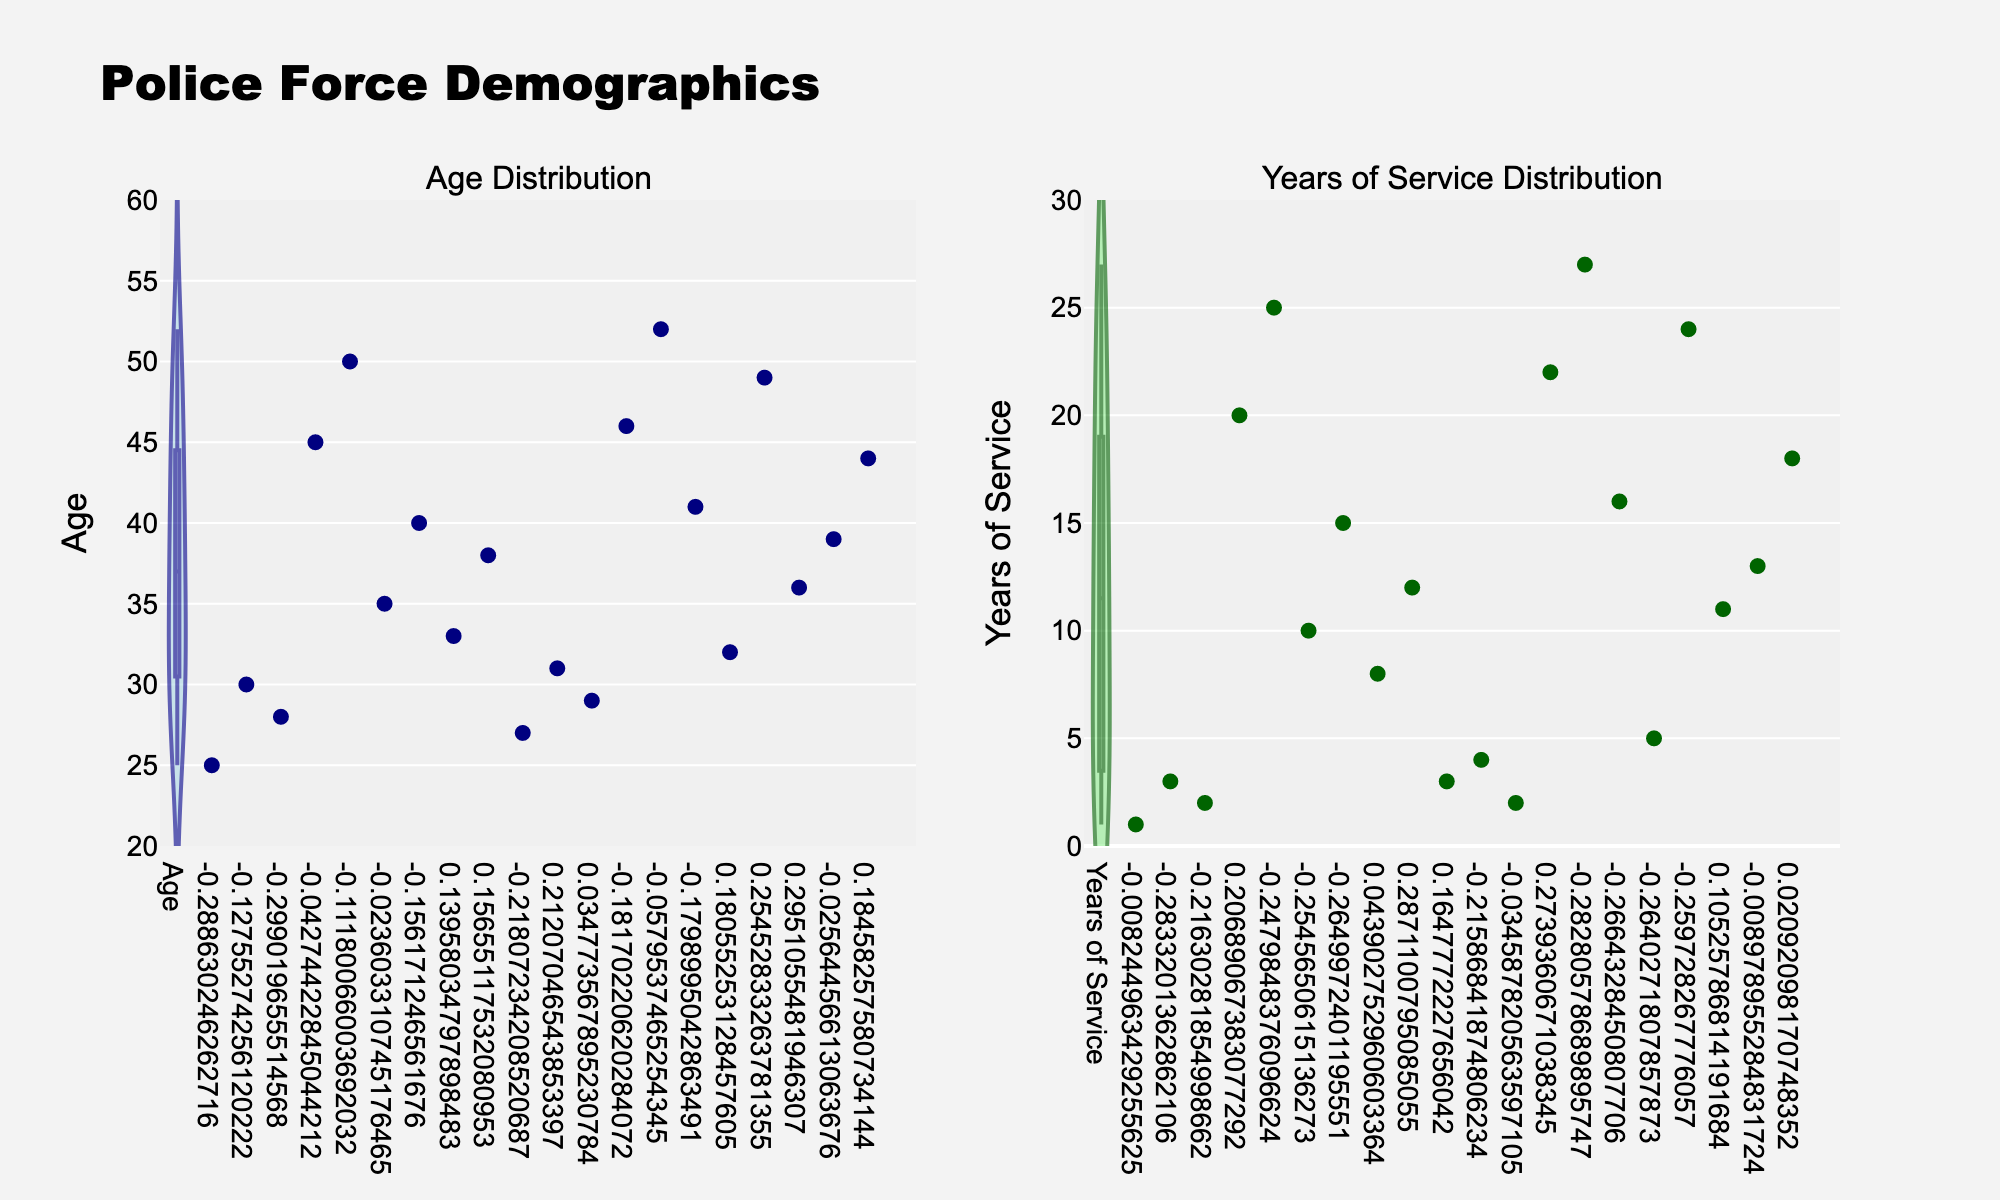What colors are used in the Age distribution violin plot? The Age distribution violin plot uses dark blue for the outline and light blue for the fill color; additionally, navy color markers are used.
Answer: Dark blue, light blue, navy How many data points are shown in the Age distribution violin plot? By counting the number of markers in the Age distribution violin plot, we see there are 20 distinct points.
Answer: 20 Which plot shows a wider distribution range, Age or Years of Service? By comparing the ranges visible in the two violin plots, the Age distribution spans from about 25 to 52, while the Years of Service spans from 1 to 27, indicating that the Age distribution has a wider range.
Answer: Age What is the approximate median value for the Years of Service distribution? The median value in a violin plot is typically where the plot is the widest. For the Years of Service distribution, the widest part appears around 12 years.
Answer: 12 years What does the highest-density age group seem to be? In the Age distribution violin plot, the highest density, indicated by the widest part of the plot, appears to be around 35 years.
Answer: Around 35 years How do the maximum values for Age and Years of Service distributions compare? By observing the top ends of the violin plots, the maximum Age is about 52 years, whereas the maximum for Years of Service is about 27 years.
Answer: The maximum Age is higher Which distribution appears to have more outliers, Age or Years of Service? Based on the spread and density in the violin plots, the Years of Service distribution has a less regular shape with more spread-out values, indicating potentially more outliers compared to the more compact Age distribution.
Answer: Years of Service Are there more data points above or below the median Age? Since the median splits the data into two equal parts and knowing the plot indicates a higher density around 35 years, we infer there are more points below the median.
Answer: Below What is the title of the entire subplot figure? The title located at the top center of the figure reads "Police Force Demographics."
Answer: Police Force Demographics Is the y-axis range the same for both subplots? Observing the y-axis labels and ticks, the Age distribution ranges from 20 to 60 years, while the Years of Service ranges from 0 to 30 years, indicating the ranges are different.
Answer: No 